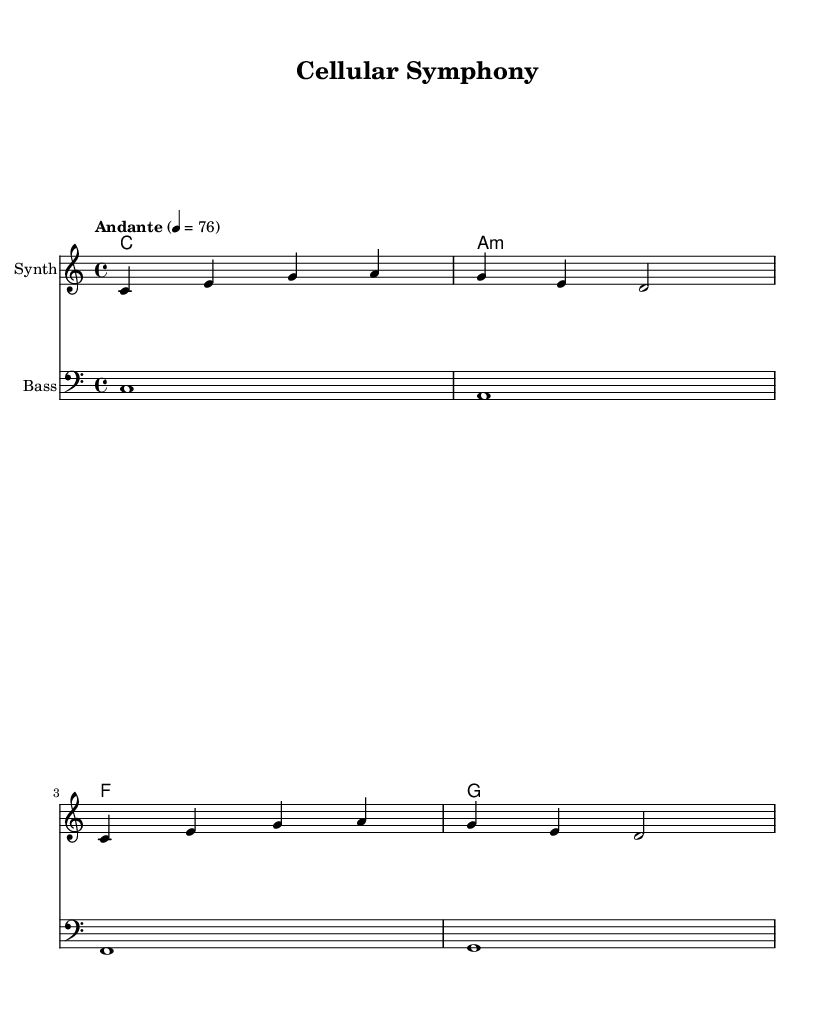What is the key signature of this music? The key signature indicates that the piece is in C major, which is defined by having no sharps or flats. This is visible in the absence of sharps or flats in the key signature section of the sheet music.
Answer: C major What is the time signature of this piece? The time signature is 4/4, which means there are four beats per measure and the quarter note gets one beat. This is obviously stated at the beginning of the score section in the sheet music.
Answer: 4/4 What is the indicated tempo for the music? The tempo marking of "Andante" indicates a moderate pace, typically around 76 beats per minute. This is explicitly noted in the tempo direction at the start of the score.
Answer: Andante, 76 What type of instrument is indicated for the melody? The instrument specified for the melody staff is a "Synth," which is shown in the instrument name label at the beginning of the melody staff in the sheet music.
Answer: Synth What is the chord progression used in this piece? The chord progression consists of the following chords: C major, A minor, F major, and G major. This progression is structured as a harmonic sequence visually listed in the chord names section.
Answer: C, A minor, F, G What is the role of the bass section in this composition? The bass section provides a foundational harmonic support by playing the root notes of the chords, specifically C, A, F, and G, which mirrors the harmonies present in the chord progression. This is illustrated by the notes and their rhythmic patterns in the bass staff.
Answer: Harmonic support 